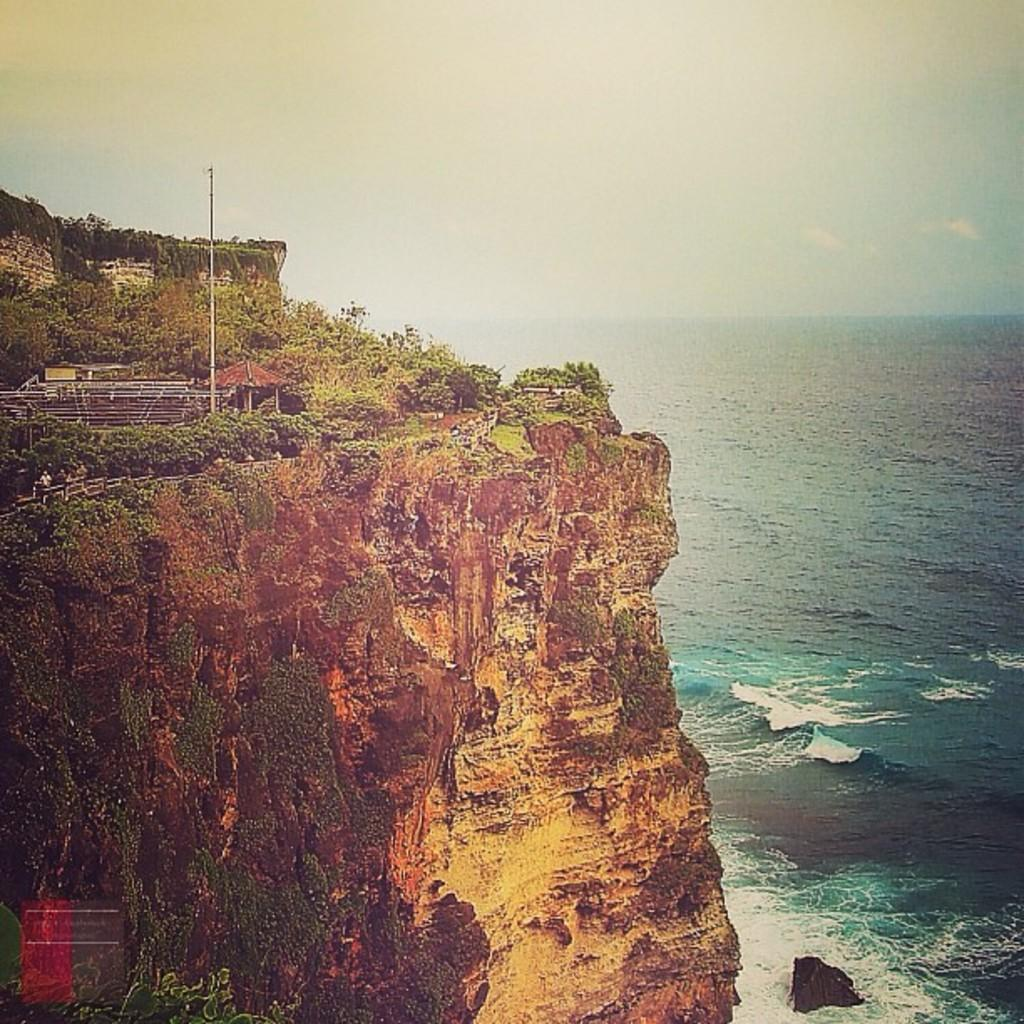What type of landform is located on the left side of the image? There is a mountain on the left side of the image. What type of body of water is on the right side of the image? There is a sea on the right side of the image. What is visible at the top of the image? The sky is visible at the top of the image. What type of iron can be seen in the image? There is no iron present in the image; it features a mountain, sea, and sky. What flavor of cattle can be seen grazing on the mountain in the image? There are no cattle present in the image, and therefore no flavor can be determined. 